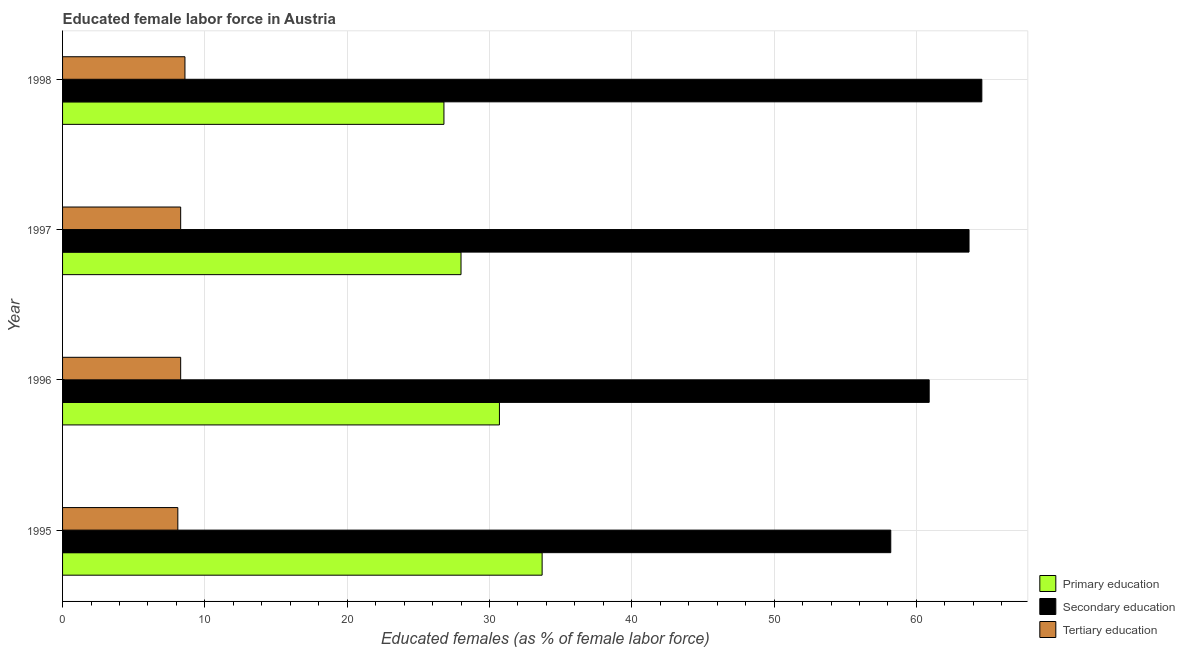Are the number of bars per tick equal to the number of legend labels?
Your answer should be very brief. Yes. Are the number of bars on each tick of the Y-axis equal?
Your response must be concise. Yes. How many bars are there on the 3rd tick from the top?
Your response must be concise. 3. What is the label of the 1st group of bars from the top?
Give a very brief answer. 1998. Across all years, what is the maximum percentage of female labor force who received secondary education?
Provide a short and direct response. 64.6. Across all years, what is the minimum percentage of female labor force who received secondary education?
Give a very brief answer. 58.2. In which year was the percentage of female labor force who received tertiary education minimum?
Offer a very short reply. 1995. What is the total percentage of female labor force who received secondary education in the graph?
Give a very brief answer. 247.4. What is the difference between the percentage of female labor force who received primary education in 1995 and that in 1998?
Your answer should be very brief. 6.9. What is the difference between the percentage of female labor force who received tertiary education in 1995 and the percentage of female labor force who received secondary education in 1998?
Your response must be concise. -56.5. What is the average percentage of female labor force who received tertiary education per year?
Provide a succinct answer. 8.32. In the year 1997, what is the difference between the percentage of female labor force who received primary education and percentage of female labor force who received tertiary education?
Provide a succinct answer. 19.7. In how many years, is the percentage of female labor force who received secondary education greater than 32 %?
Offer a terse response. 4. What is the ratio of the percentage of female labor force who received tertiary education in 1995 to that in 1998?
Your answer should be compact. 0.94. Is the percentage of female labor force who received secondary education in 1997 less than that in 1998?
Offer a terse response. Yes. What is the difference between the highest and the second highest percentage of female labor force who received tertiary education?
Your response must be concise. 0.3. In how many years, is the percentage of female labor force who received tertiary education greater than the average percentage of female labor force who received tertiary education taken over all years?
Your answer should be very brief. 1. How many years are there in the graph?
Your answer should be compact. 4. Does the graph contain any zero values?
Provide a succinct answer. No. Does the graph contain grids?
Your response must be concise. Yes. What is the title of the graph?
Give a very brief answer. Educated female labor force in Austria. What is the label or title of the X-axis?
Make the answer very short. Educated females (as % of female labor force). What is the label or title of the Y-axis?
Provide a succinct answer. Year. What is the Educated females (as % of female labor force) of Primary education in 1995?
Give a very brief answer. 33.7. What is the Educated females (as % of female labor force) in Secondary education in 1995?
Your answer should be compact. 58.2. What is the Educated females (as % of female labor force) of Tertiary education in 1995?
Your response must be concise. 8.1. What is the Educated females (as % of female labor force) of Primary education in 1996?
Your response must be concise. 30.7. What is the Educated females (as % of female labor force) of Secondary education in 1996?
Keep it short and to the point. 60.9. What is the Educated females (as % of female labor force) of Tertiary education in 1996?
Your answer should be compact. 8.3. What is the Educated females (as % of female labor force) of Primary education in 1997?
Make the answer very short. 28. What is the Educated females (as % of female labor force) of Secondary education in 1997?
Offer a very short reply. 63.7. What is the Educated females (as % of female labor force) in Tertiary education in 1997?
Make the answer very short. 8.3. What is the Educated females (as % of female labor force) of Primary education in 1998?
Make the answer very short. 26.8. What is the Educated females (as % of female labor force) of Secondary education in 1998?
Make the answer very short. 64.6. What is the Educated females (as % of female labor force) of Tertiary education in 1998?
Offer a very short reply. 8.6. Across all years, what is the maximum Educated females (as % of female labor force) in Primary education?
Your answer should be compact. 33.7. Across all years, what is the maximum Educated females (as % of female labor force) in Secondary education?
Keep it short and to the point. 64.6. Across all years, what is the maximum Educated females (as % of female labor force) of Tertiary education?
Make the answer very short. 8.6. Across all years, what is the minimum Educated females (as % of female labor force) in Primary education?
Provide a succinct answer. 26.8. Across all years, what is the minimum Educated females (as % of female labor force) in Secondary education?
Provide a succinct answer. 58.2. Across all years, what is the minimum Educated females (as % of female labor force) in Tertiary education?
Make the answer very short. 8.1. What is the total Educated females (as % of female labor force) of Primary education in the graph?
Offer a very short reply. 119.2. What is the total Educated females (as % of female labor force) of Secondary education in the graph?
Ensure brevity in your answer.  247.4. What is the total Educated females (as % of female labor force) in Tertiary education in the graph?
Ensure brevity in your answer.  33.3. What is the difference between the Educated females (as % of female labor force) of Secondary education in 1995 and that in 1997?
Make the answer very short. -5.5. What is the difference between the Educated females (as % of female labor force) in Tertiary education in 1995 and that in 1998?
Give a very brief answer. -0.5. What is the difference between the Educated females (as % of female labor force) of Primary education in 1996 and that in 1998?
Provide a succinct answer. 3.9. What is the difference between the Educated females (as % of female labor force) of Secondary education in 1996 and that in 1998?
Your answer should be very brief. -3.7. What is the difference between the Educated females (as % of female labor force) of Tertiary education in 1996 and that in 1998?
Give a very brief answer. -0.3. What is the difference between the Educated females (as % of female labor force) in Primary education in 1997 and that in 1998?
Your answer should be very brief. 1.2. What is the difference between the Educated females (as % of female labor force) of Primary education in 1995 and the Educated females (as % of female labor force) of Secondary education in 1996?
Your response must be concise. -27.2. What is the difference between the Educated females (as % of female labor force) of Primary education in 1995 and the Educated females (as % of female labor force) of Tertiary education in 1996?
Your response must be concise. 25.4. What is the difference between the Educated females (as % of female labor force) in Secondary education in 1995 and the Educated females (as % of female labor force) in Tertiary education in 1996?
Make the answer very short. 49.9. What is the difference between the Educated females (as % of female labor force) in Primary education in 1995 and the Educated females (as % of female labor force) in Secondary education in 1997?
Provide a short and direct response. -30. What is the difference between the Educated females (as % of female labor force) in Primary education in 1995 and the Educated females (as % of female labor force) in Tertiary education in 1997?
Your answer should be very brief. 25.4. What is the difference between the Educated females (as % of female labor force) of Secondary education in 1995 and the Educated females (as % of female labor force) of Tertiary education in 1997?
Provide a short and direct response. 49.9. What is the difference between the Educated females (as % of female labor force) in Primary education in 1995 and the Educated females (as % of female labor force) in Secondary education in 1998?
Make the answer very short. -30.9. What is the difference between the Educated females (as % of female labor force) of Primary education in 1995 and the Educated females (as % of female labor force) of Tertiary education in 1998?
Give a very brief answer. 25.1. What is the difference between the Educated females (as % of female labor force) in Secondary education in 1995 and the Educated females (as % of female labor force) in Tertiary education in 1998?
Keep it short and to the point. 49.6. What is the difference between the Educated females (as % of female labor force) of Primary education in 1996 and the Educated females (as % of female labor force) of Secondary education in 1997?
Provide a short and direct response. -33. What is the difference between the Educated females (as % of female labor force) in Primary education in 1996 and the Educated females (as % of female labor force) in Tertiary education in 1997?
Make the answer very short. 22.4. What is the difference between the Educated females (as % of female labor force) in Secondary education in 1996 and the Educated females (as % of female labor force) in Tertiary education in 1997?
Keep it short and to the point. 52.6. What is the difference between the Educated females (as % of female labor force) of Primary education in 1996 and the Educated females (as % of female labor force) of Secondary education in 1998?
Offer a very short reply. -33.9. What is the difference between the Educated females (as % of female labor force) in Primary education in 1996 and the Educated females (as % of female labor force) in Tertiary education in 1998?
Your answer should be compact. 22.1. What is the difference between the Educated females (as % of female labor force) in Secondary education in 1996 and the Educated females (as % of female labor force) in Tertiary education in 1998?
Make the answer very short. 52.3. What is the difference between the Educated females (as % of female labor force) in Primary education in 1997 and the Educated females (as % of female labor force) in Secondary education in 1998?
Offer a terse response. -36.6. What is the difference between the Educated females (as % of female labor force) of Primary education in 1997 and the Educated females (as % of female labor force) of Tertiary education in 1998?
Ensure brevity in your answer.  19.4. What is the difference between the Educated females (as % of female labor force) of Secondary education in 1997 and the Educated females (as % of female labor force) of Tertiary education in 1998?
Give a very brief answer. 55.1. What is the average Educated females (as % of female labor force) in Primary education per year?
Ensure brevity in your answer.  29.8. What is the average Educated females (as % of female labor force) of Secondary education per year?
Offer a terse response. 61.85. What is the average Educated females (as % of female labor force) of Tertiary education per year?
Offer a terse response. 8.32. In the year 1995, what is the difference between the Educated females (as % of female labor force) of Primary education and Educated females (as % of female labor force) of Secondary education?
Your answer should be very brief. -24.5. In the year 1995, what is the difference between the Educated females (as % of female labor force) of Primary education and Educated females (as % of female labor force) of Tertiary education?
Your answer should be compact. 25.6. In the year 1995, what is the difference between the Educated females (as % of female labor force) in Secondary education and Educated females (as % of female labor force) in Tertiary education?
Ensure brevity in your answer.  50.1. In the year 1996, what is the difference between the Educated females (as % of female labor force) in Primary education and Educated females (as % of female labor force) in Secondary education?
Your response must be concise. -30.2. In the year 1996, what is the difference between the Educated females (as % of female labor force) in Primary education and Educated females (as % of female labor force) in Tertiary education?
Provide a short and direct response. 22.4. In the year 1996, what is the difference between the Educated females (as % of female labor force) in Secondary education and Educated females (as % of female labor force) in Tertiary education?
Keep it short and to the point. 52.6. In the year 1997, what is the difference between the Educated females (as % of female labor force) in Primary education and Educated females (as % of female labor force) in Secondary education?
Your answer should be very brief. -35.7. In the year 1997, what is the difference between the Educated females (as % of female labor force) in Primary education and Educated females (as % of female labor force) in Tertiary education?
Keep it short and to the point. 19.7. In the year 1997, what is the difference between the Educated females (as % of female labor force) in Secondary education and Educated females (as % of female labor force) in Tertiary education?
Ensure brevity in your answer.  55.4. In the year 1998, what is the difference between the Educated females (as % of female labor force) of Primary education and Educated females (as % of female labor force) of Secondary education?
Ensure brevity in your answer.  -37.8. In the year 1998, what is the difference between the Educated females (as % of female labor force) of Primary education and Educated females (as % of female labor force) of Tertiary education?
Keep it short and to the point. 18.2. What is the ratio of the Educated females (as % of female labor force) in Primary education in 1995 to that in 1996?
Your answer should be very brief. 1.1. What is the ratio of the Educated females (as % of female labor force) of Secondary education in 1995 to that in 1996?
Your response must be concise. 0.96. What is the ratio of the Educated females (as % of female labor force) of Tertiary education in 1995 to that in 1996?
Provide a short and direct response. 0.98. What is the ratio of the Educated females (as % of female labor force) of Primary education in 1995 to that in 1997?
Give a very brief answer. 1.2. What is the ratio of the Educated females (as % of female labor force) of Secondary education in 1995 to that in 1997?
Make the answer very short. 0.91. What is the ratio of the Educated females (as % of female labor force) of Tertiary education in 1995 to that in 1997?
Your response must be concise. 0.98. What is the ratio of the Educated females (as % of female labor force) in Primary education in 1995 to that in 1998?
Keep it short and to the point. 1.26. What is the ratio of the Educated females (as % of female labor force) in Secondary education in 1995 to that in 1998?
Your answer should be very brief. 0.9. What is the ratio of the Educated females (as % of female labor force) in Tertiary education in 1995 to that in 1998?
Make the answer very short. 0.94. What is the ratio of the Educated females (as % of female labor force) in Primary education in 1996 to that in 1997?
Your answer should be compact. 1.1. What is the ratio of the Educated females (as % of female labor force) in Secondary education in 1996 to that in 1997?
Your answer should be very brief. 0.96. What is the ratio of the Educated females (as % of female labor force) in Primary education in 1996 to that in 1998?
Your answer should be compact. 1.15. What is the ratio of the Educated females (as % of female labor force) in Secondary education in 1996 to that in 1998?
Offer a terse response. 0.94. What is the ratio of the Educated females (as % of female labor force) in Tertiary education in 1996 to that in 1998?
Your response must be concise. 0.97. What is the ratio of the Educated females (as % of female labor force) of Primary education in 1997 to that in 1998?
Give a very brief answer. 1.04. What is the ratio of the Educated females (as % of female labor force) in Secondary education in 1997 to that in 1998?
Provide a short and direct response. 0.99. What is the ratio of the Educated females (as % of female labor force) in Tertiary education in 1997 to that in 1998?
Provide a succinct answer. 0.97. What is the difference between the highest and the second highest Educated females (as % of female labor force) in Secondary education?
Provide a short and direct response. 0.9. What is the difference between the highest and the lowest Educated females (as % of female labor force) of Secondary education?
Offer a terse response. 6.4. 